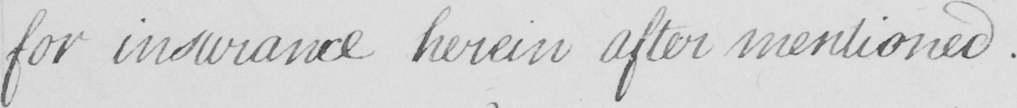What text is written in this handwritten line? for insurance herein after mentioned . 